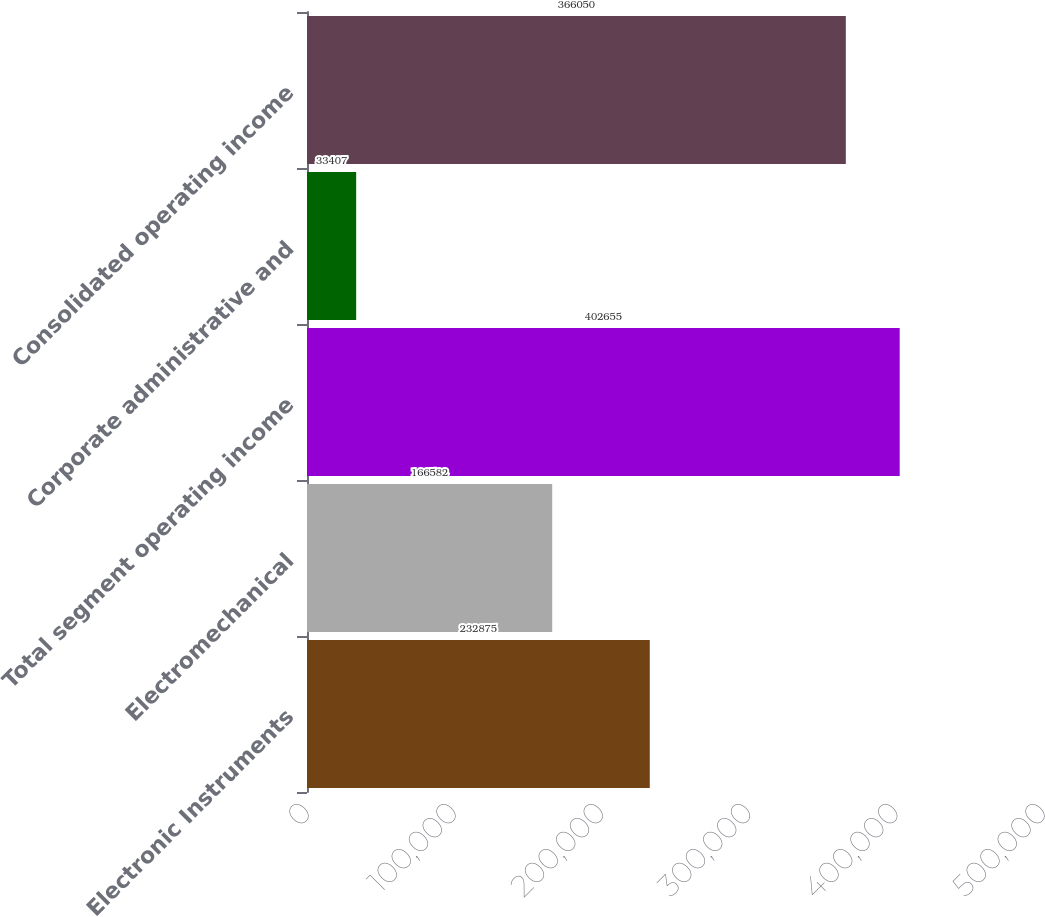Convert chart to OTSL. <chart><loc_0><loc_0><loc_500><loc_500><bar_chart><fcel>Electronic Instruments<fcel>Electromechanical<fcel>Total segment operating income<fcel>Corporate administrative and<fcel>Consolidated operating income<nl><fcel>232875<fcel>166582<fcel>402655<fcel>33407<fcel>366050<nl></chart> 